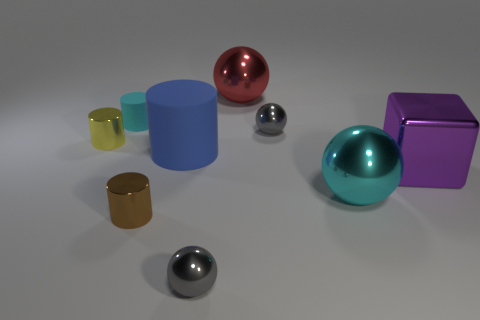Subtract 1 cylinders. How many cylinders are left? 3 Add 1 big cyan metallic cylinders. How many objects exist? 10 Subtract all cubes. How many objects are left? 8 Subtract all tiny brown metal cylinders. Subtract all big red balls. How many objects are left? 7 Add 8 big purple metallic things. How many big purple metallic things are left? 9 Add 2 small brown shiny objects. How many small brown shiny objects exist? 3 Subtract 0 gray cubes. How many objects are left? 9 